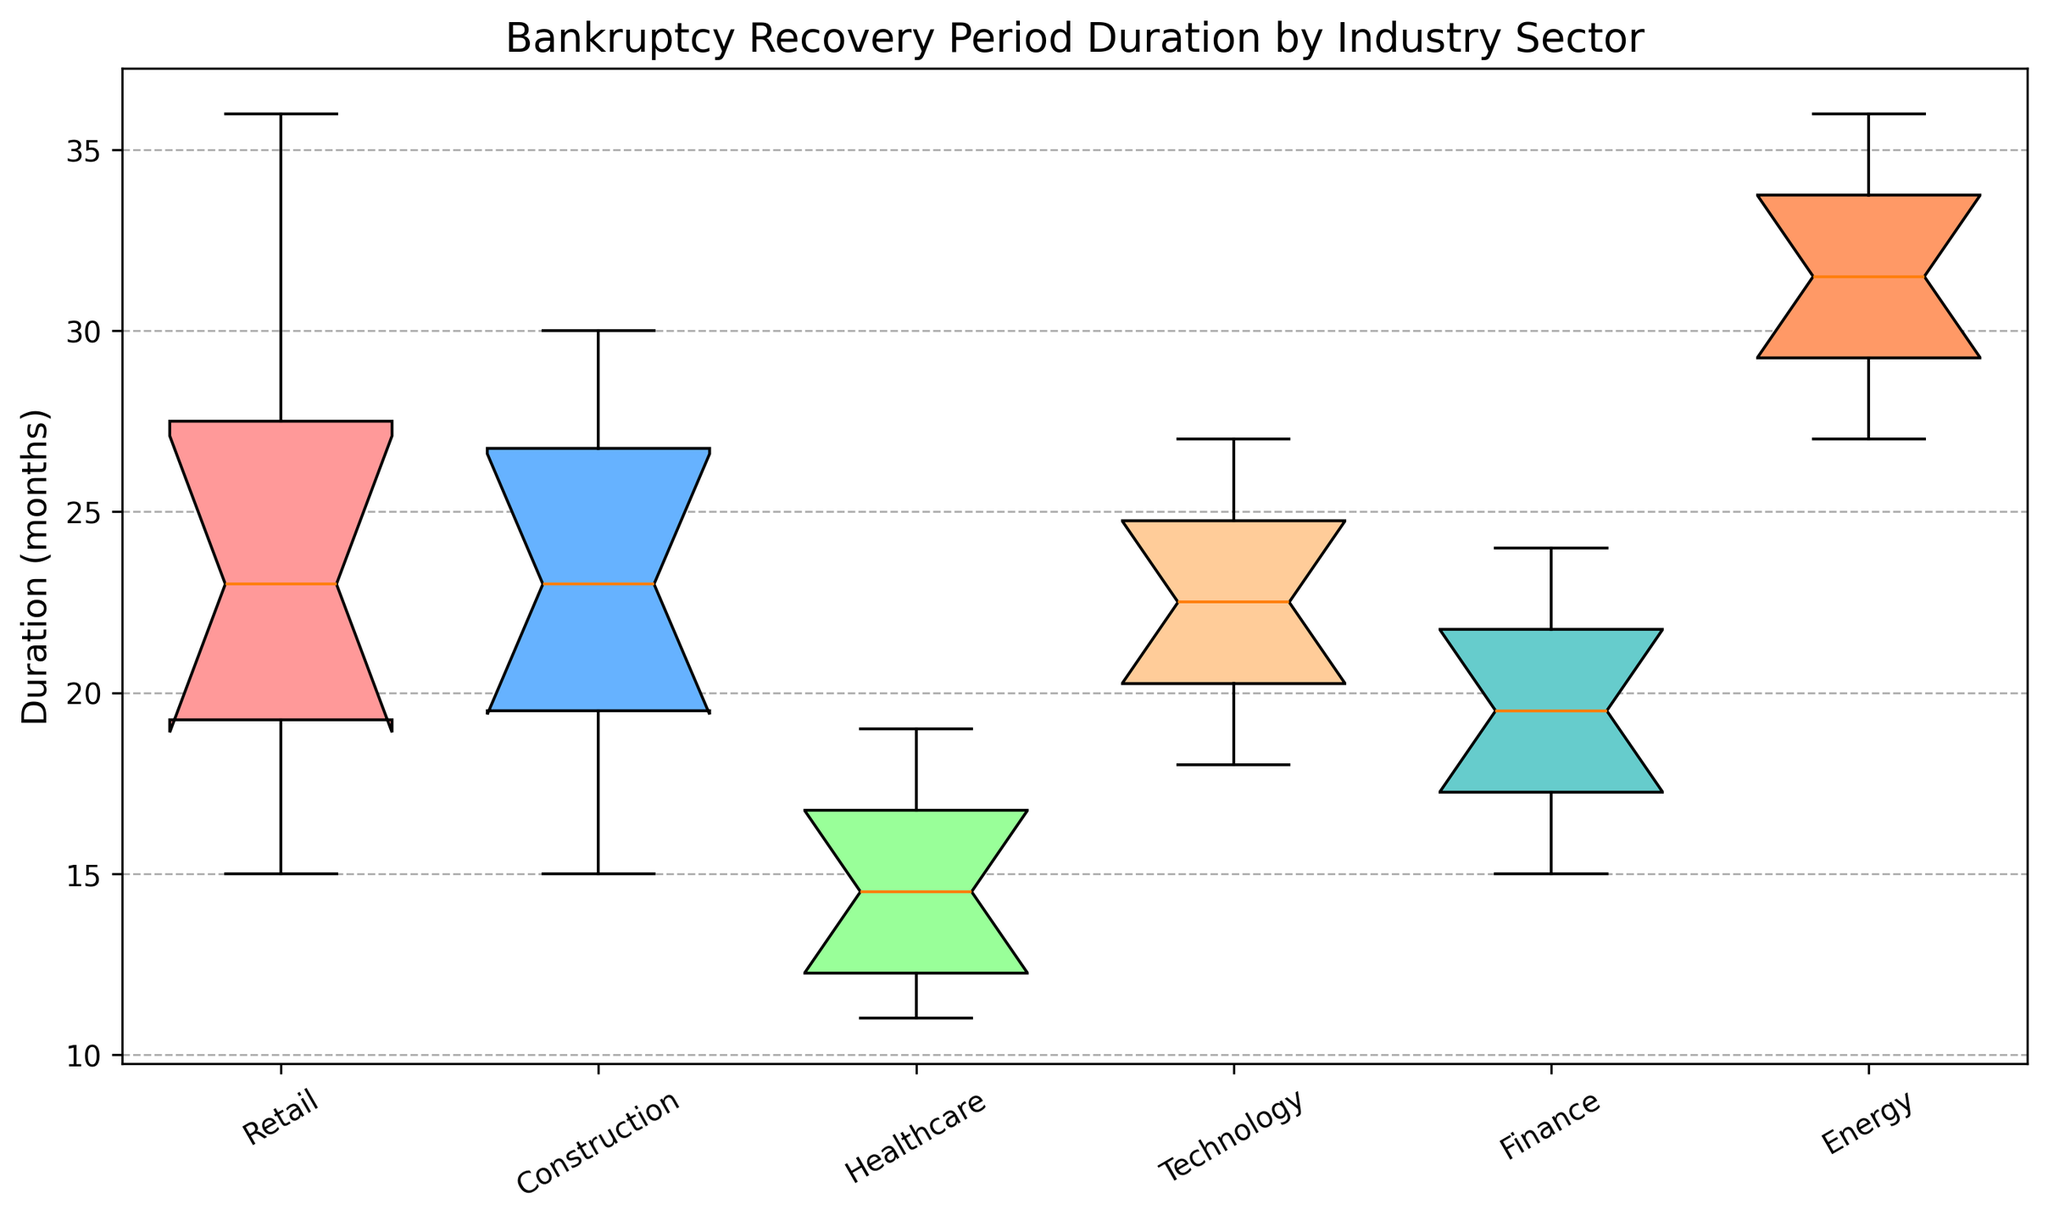Which industry sector has the shortest median bankruptcy recovery period? Look at the line inside the box for each industry. The shortest line indicates the shortest median recovery period.
Answer: Healthcare Which sector shows the widest range of recovery periods? Compare the length of the whiskers (the lines extending from the box) across all sectors. The sector with the longest whiskers has the widest range.
Answer: Energy What is the interquartile range (IQR) for the Retail industry? The IQR is the difference between the 75th percentile (top of the box) and the 25th percentile (bottom of the box). Identify these values visually for the Retail industry.
Answer: Roughly 8 months Does the Technology sector have a higher median recovery period than the Finance sector? Compare the positions of the lines inside the boxes for Technology and Finance. The higher line indicates a higher median.
Answer: Yes What is the approximate maximum recovery period for the Construction sector? Locate the highest point (whisker or outlier) for the Construction sector.
Answer: Around 30 months Which industry sectors have outliers, and what is the duration of the outliers? Identify any points beyond the whiskers for each sector. These points are the outliers.
Answer: None (no points beyond whiskers) Which industry shows the most consistent recovery period, based on the box plot distribution? Consistency can be inferred from a smaller box and shorter whiskers, indicating less spread. Identify the industry with the smallest box and whiskers.
Answer: Healthcare Compare the lower whiskers for the Retail and Energy sectors. Which one is lower, and what does this signify? Look at the bottom ends of the whiskers for these two sectors. The lower whisker indicates a shorter minimum recovery period.
Answer: Retail; signifies a shorter minimum period What is the 75th percentile for the Technology sector? The 75th percentile is the top edge of the box for the Technology sector. Identify this value visually on the plot.
Answer: Roughly 25 months Which sector has the most recovery periods clustered around the median? A high concentration of data around the median will result in a smaller IQR and shorter whiskers. Identify the sector with the most compact box plot.
Answer: Healthcare 